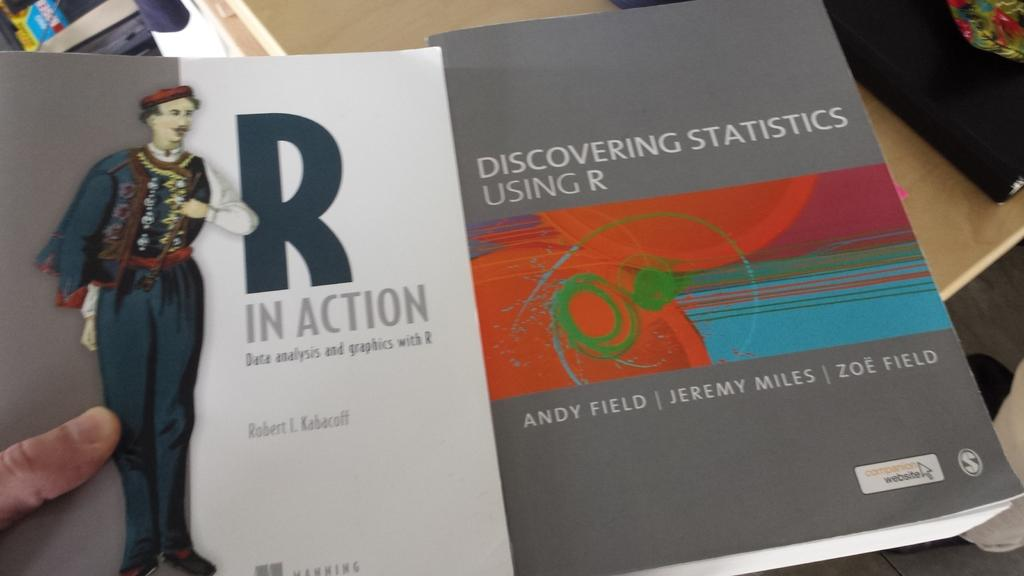Provide a one-sentence caption for the provided image. Two books about statistics for using and discovering R. 